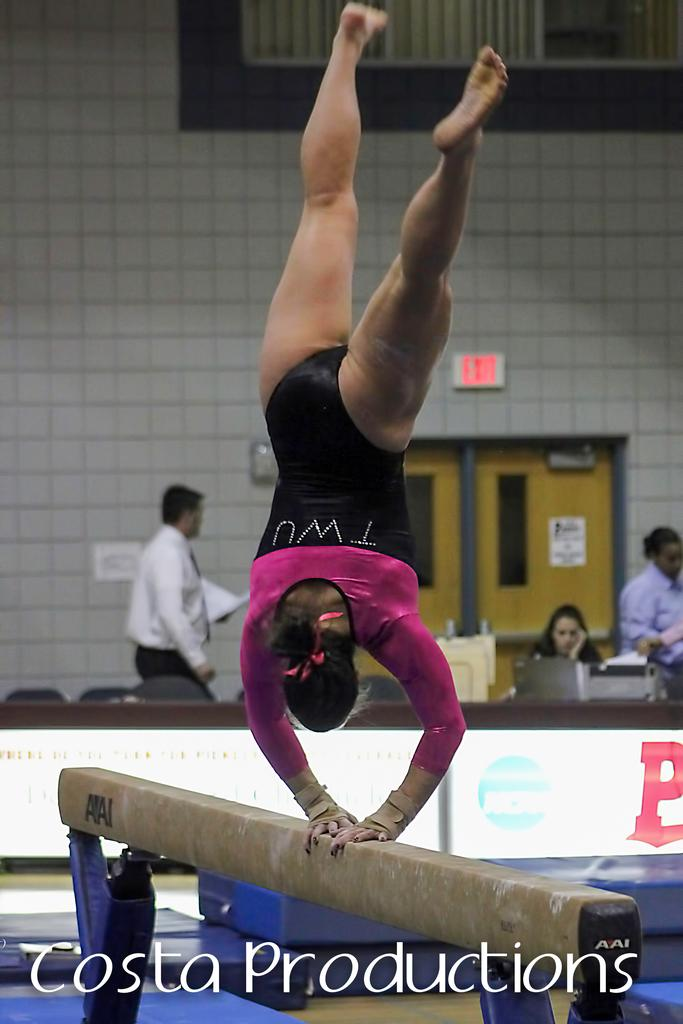Who is the main subject in the image? There is a woman in the image. What is the woman doing in the image? The woman is on a balance beam. What can be seen in the background of the image? There are people, doors, a wall, and curtains in the background of the image. Can you hear a bird singing in the image? There is no bird present in the image, so it is not possible to hear a bird singing. 